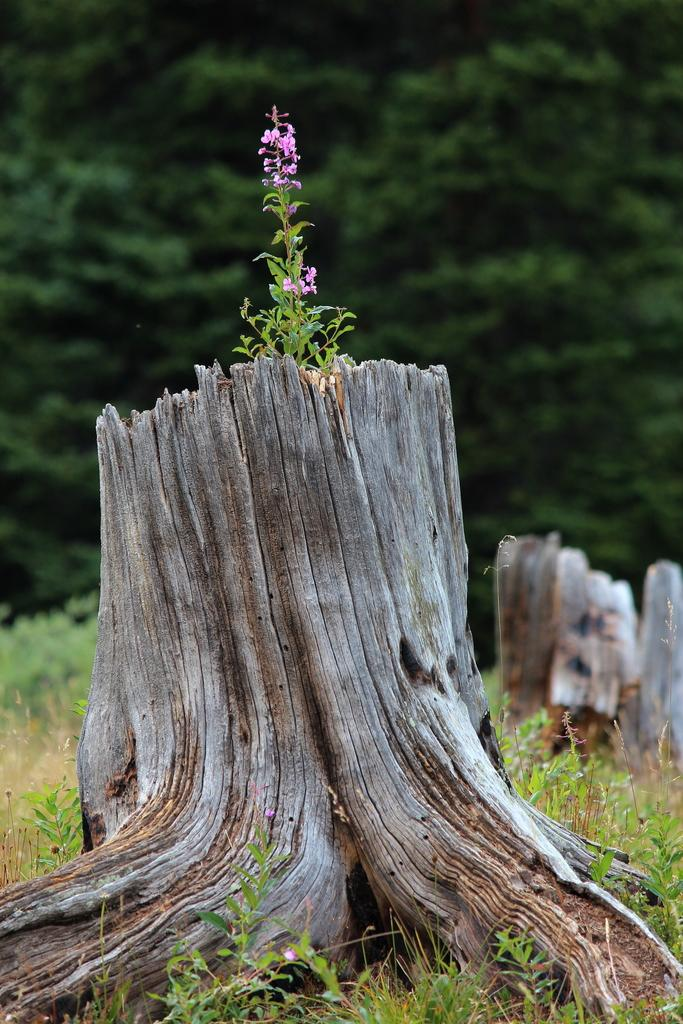What is the main subject in the image? The main subject in the image is a tree trunk. What type of vegetation can be seen in the image? There is grass and a plant visible in the image. What color are the flowers in the image? The flowers in the image are pink. How would you describe the background of the image? The background of the image is blurred. What type of disease is affecting the tree trunk in the image? There is no indication of any disease affecting the tree trunk in the image. What is the chin of the plant in the image like? There is no chin present on the plant in the image, as plants do not have chins. 